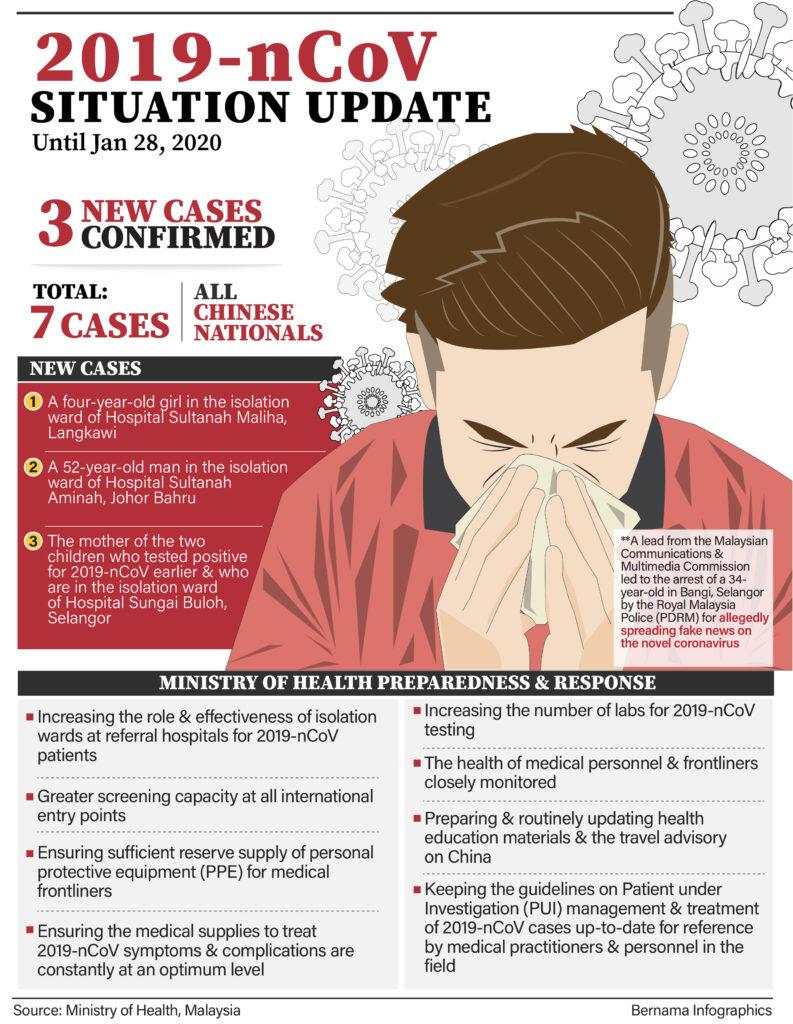Draw attention to some important aspects in this diagram. The total number of cases is 7. 